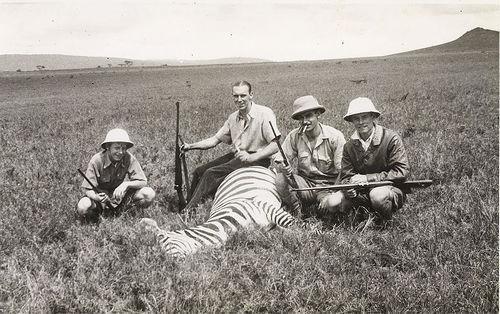How many people are there?
Give a very brief answer. 4. 